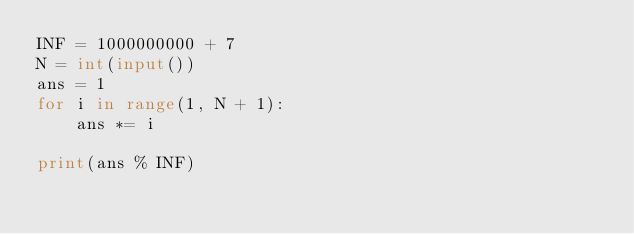<code> <loc_0><loc_0><loc_500><loc_500><_Python_>INF = 1000000000 + 7
N = int(input())
ans = 1
for i in range(1, N + 1):
    ans *= i

print(ans % INF)
</code> 